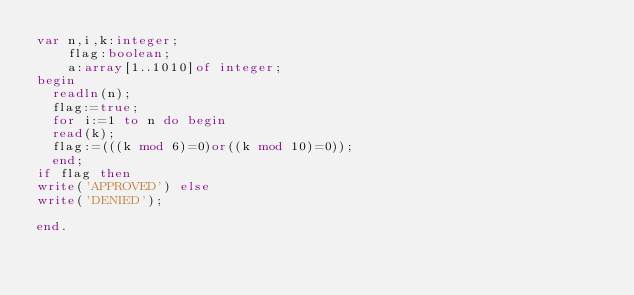<code> <loc_0><loc_0><loc_500><loc_500><_Pascal_>var n,i,k:integer;
    flag:boolean;
    a:array[1..1010]of integer;
begin
  readln(n);
  flag:=true;
  for i:=1 to n do begin
  read(k);
  flag:=(((k mod 6)=0)or((k mod 10)=0));
  end;
if flag then 
write('APPROVED') else
write('DENIED');

end.
</code> 